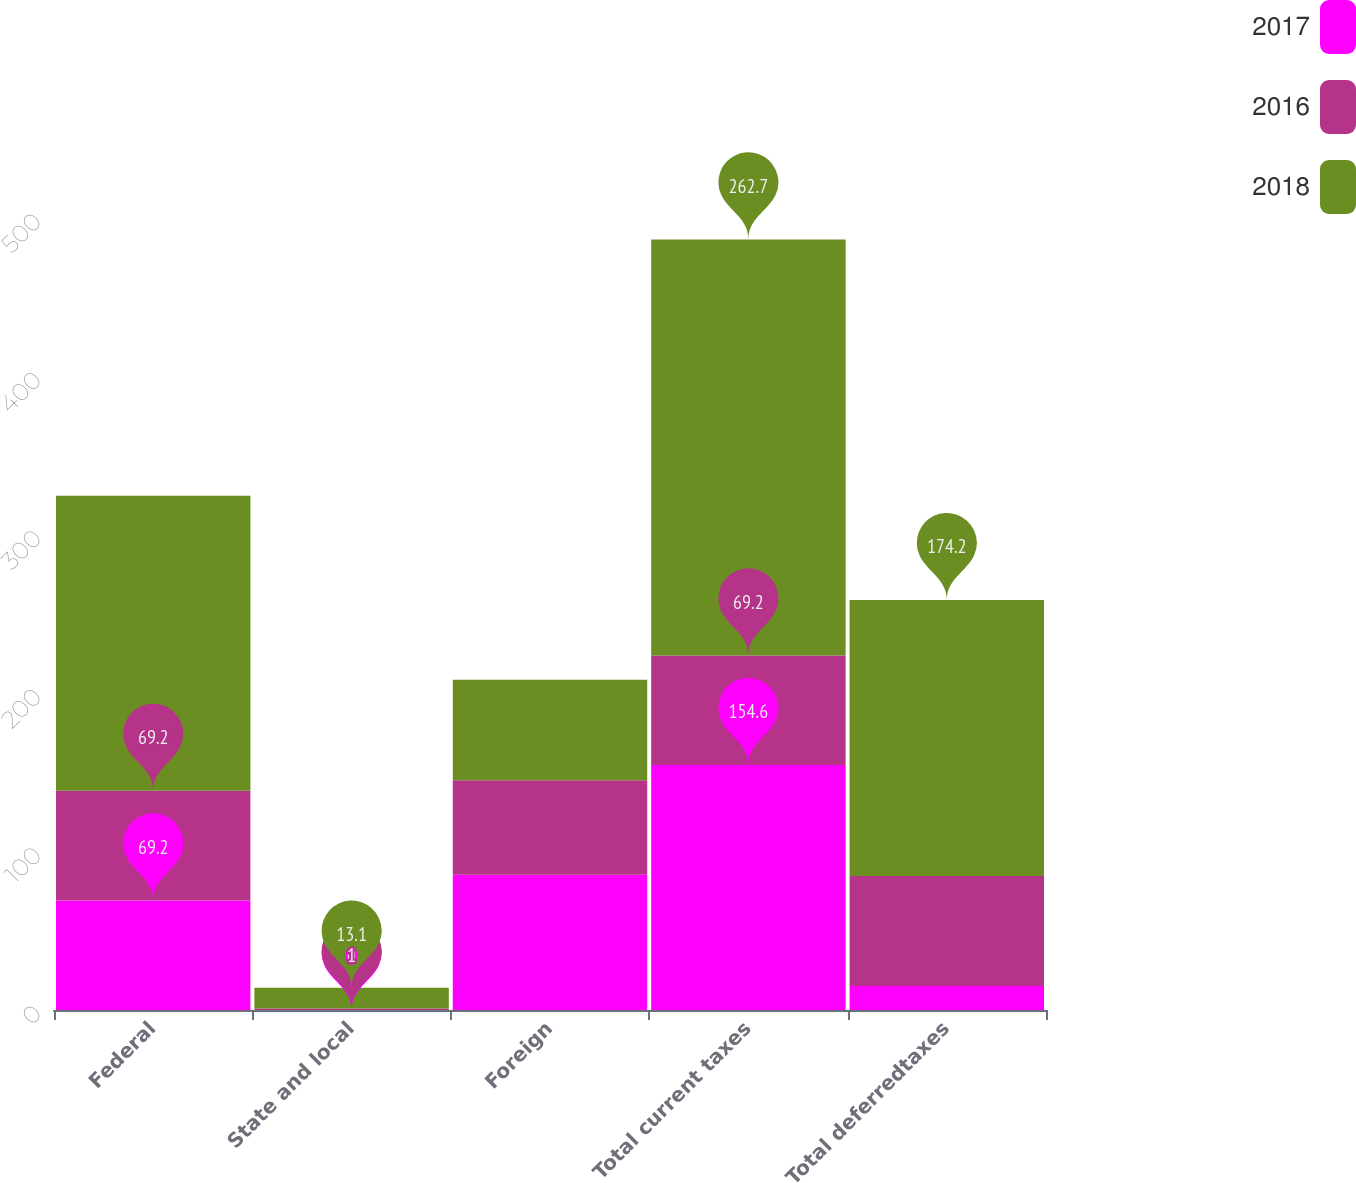Convert chart. <chart><loc_0><loc_0><loc_500><loc_500><stacked_bar_chart><ecel><fcel>Federal<fcel>State and local<fcel>Foreign<fcel>Total current taxes<fcel>Total deferredtaxes<nl><fcel>2017<fcel>69.2<fcel>0<fcel>85.4<fcel>154.6<fcel>15.1<nl><fcel>2016<fcel>69.2<fcel>1<fcel>59.7<fcel>69.2<fcel>69.5<nl><fcel>2018<fcel>186.2<fcel>13.1<fcel>63.4<fcel>262.7<fcel>174.2<nl></chart> 